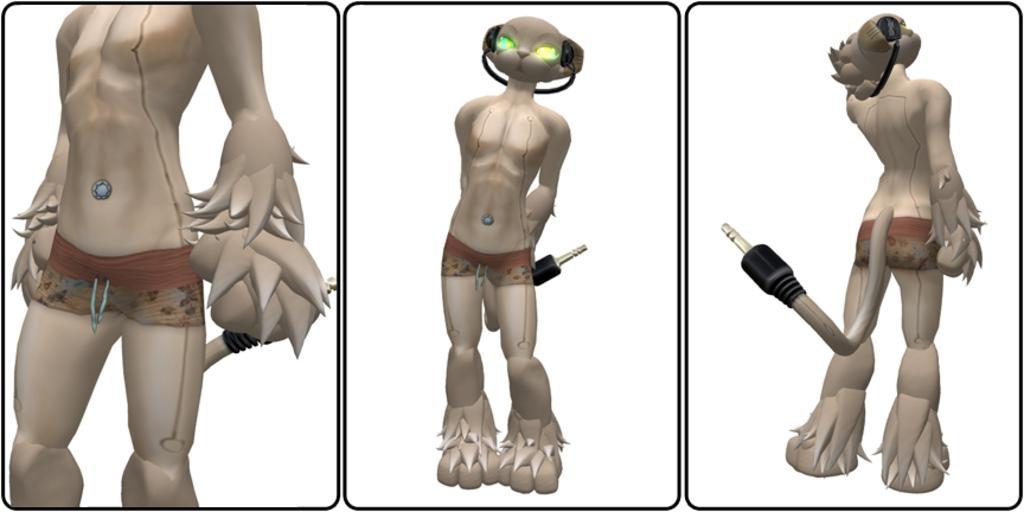How would you summarize this image in a sentence or two? This is an animated image, in this image there is an object that looks like an animal, the animal is wearing headphones, the background of the image is white in color. 